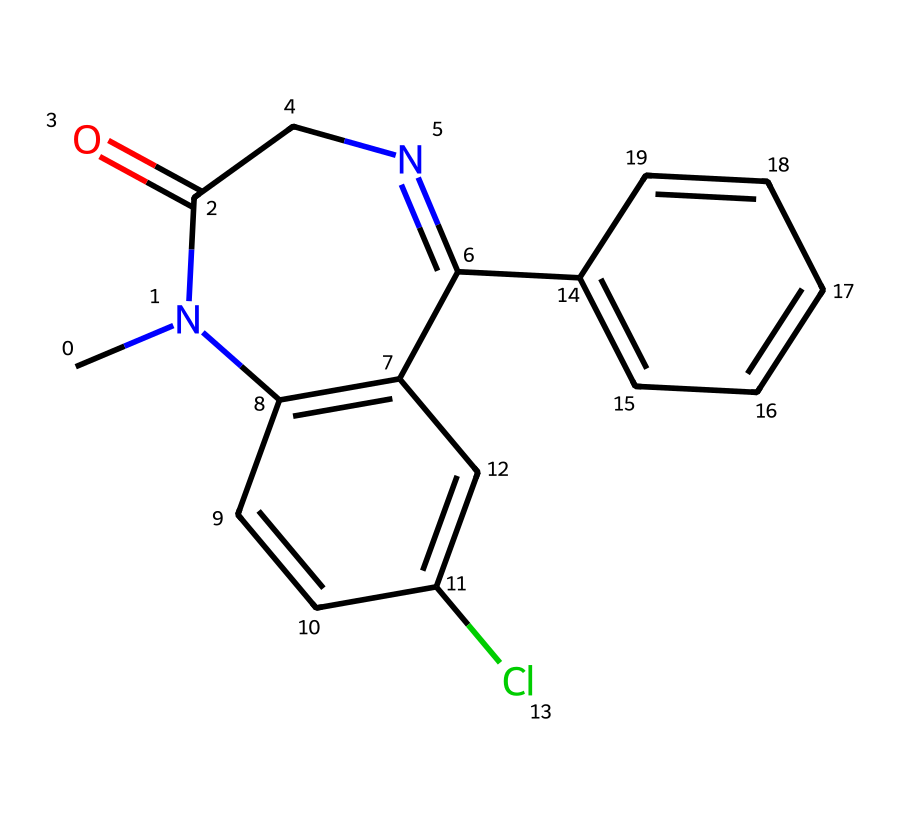What is the molecular formula of diazepam? To derive the molecular formula, count the number of each type of atom present in the SMILES representation. There are 16 carbon (C) atoms, 14 hydrogen (H) atoms, 2 nitrogen (N) atoms, and 1 oxygen (O) atom. Thus, the molecular formula is C16H14N2O.
Answer: C16H14N2O How many rings are present in the diazepam structure? Analyze the SMILES string to identify cyclic structures. The presence of C=C bonds and the notation 'N' indicates rings. There are two fused aromatic rings in the diazepam structure. Counting the fused system gives a total of 2 rings.
Answer: 2 What is the role of chlorine in the diazepam structure? The chlorine atom in the diazepam structure enhances the lipophilicity, which affects the pharmacodynamics and pharmacokinetics of the drug by influencing its absorption and distribution.
Answer: enhance lipophilicity Which element serves as a part of the amide functional group in diazepam? In the molecular structure, the carbonyl (C=O) and the nitrogen (N) adjacent to it form the amide functional group. Thus, the nitrogen atom (N) in the amide group is crucial to its classification.
Answer: nitrogen How many nitrogen atoms are present in diazepam? By examining the entire SMILES representation, count the occurrences of the letter 'N'. There are two nitrogen atoms present in the diazepam chemical structure.
Answer: 2 What type of compound is diazepam classified as based on its structure? The presence of a diazepine ring and its pharmacological properties classify diazepam as a benzodiazepine. The structure includes these identifiable features, confirming this classification.
Answer: benzodiazepine What is the significance of the fused ring system in diazepam? The fused ring system in diazepam contributes to its stability and efficacy in binding to the GABA receptor, which is essential for its anxiolytic properties. Evaluating the structure shows how the fused system supports effective interaction with biological targets.
Answer: stability and efficacy 